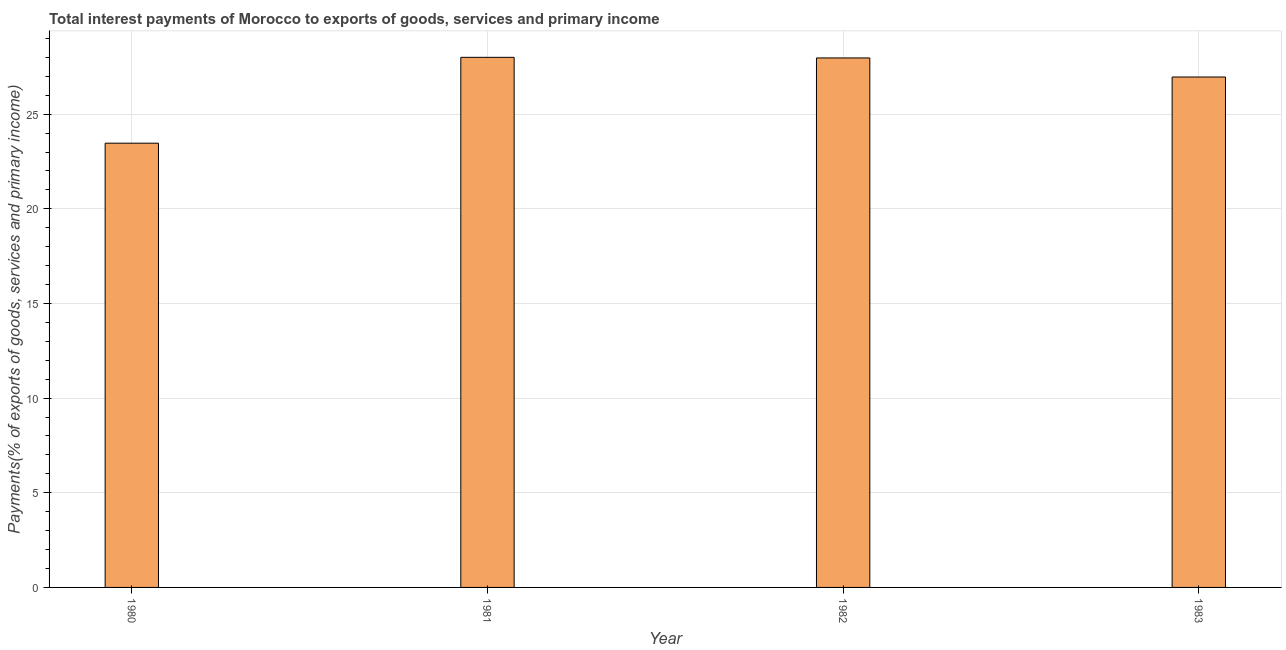Does the graph contain any zero values?
Offer a terse response. No. What is the title of the graph?
Offer a very short reply. Total interest payments of Morocco to exports of goods, services and primary income. What is the label or title of the Y-axis?
Keep it short and to the point. Payments(% of exports of goods, services and primary income). What is the total interest payments on external debt in 1981?
Provide a short and direct response. 28. Across all years, what is the maximum total interest payments on external debt?
Offer a terse response. 28. Across all years, what is the minimum total interest payments on external debt?
Offer a terse response. 23.47. In which year was the total interest payments on external debt minimum?
Offer a very short reply. 1980. What is the sum of the total interest payments on external debt?
Offer a very short reply. 106.41. What is the difference between the total interest payments on external debt in 1980 and 1982?
Provide a short and direct response. -4.5. What is the average total interest payments on external debt per year?
Provide a short and direct response. 26.6. What is the median total interest payments on external debt?
Provide a short and direct response. 27.47. What is the ratio of the total interest payments on external debt in 1980 to that in 1982?
Your answer should be very brief. 0.84. Is the total interest payments on external debt in 1980 less than that in 1982?
Your response must be concise. Yes. What is the difference between the highest and the second highest total interest payments on external debt?
Offer a very short reply. 0.03. What is the difference between the highest and the lowest total interest payments on external debt?
Give a very brief answer. 4.53. In how many years, is the total interest payments on external debt greater than the average total interest payments on external debt taken over all years?
Provide a succinct answer. 3. How many bars are there?
Your answer should be compact. 4. Are the values on the major ticks of Y-axis written in scientific E-notation?
Your answer should be very brief. No. What is the Payments(% of exports of goods, services and primary income) in 1980?
Give a very brief answer. 23.47. What is the Payments(% of exports of goods, services and primary income) of 1981?
Offer a terse response. 28. What is the Payments(% of exports of goods, services and primary income) in 1982?
Provide a short and direct response. 27.97. What is the Payments(% of exports of goods, services and primary income) of 1983?
Keep it short and to the point. 26.96. What is the difference between the Payments(% of exports of goods, services and primary income) in 1980 and 1981?
Offer a terse response. -4.53. What is the difference between the Payments(% of exports of goods, services and primary income) in 1980 and 1982?
Provide a succinct answer. -4.5. What is the difference between the Payments(% of exports of goods, services and primary income) in 1980 and 1983?
Your answer should be compact. -3.5. What is the difference between the Payments(% of exports of goods, services and primary income) in 1981 and 1982?
Your answer should be very brief. 0.03. What is the difference between the Payments(% of exports of goods, services and primary income) in 1981 and 1983?
Provide a succinct answer. 1.04. What is the difference between the Payments(% of exports of goods, services and primary income) in 1982 and 1983?
Your answer should be very brief. 1.01. What is the ratio of the Payments(% of exports of goods, services and primary income) in 1980 to that in 1981?
Your answer should be compact. 0.84. What is the ratio of the Payments(% of exports of goods, services and primary income) in 1980 to that in 1982?
Offer a very short reply. 0.84. What is the ratio of the Payments(% of exports of goods, services and primary income) in 1980 to that in 1983?
Keep it short and to the point. 0.87. What is the ratio of the Payments(% of exports of goods, services and primary income) in 1981 to that in 1983?
Give a very brief answer. 1.04. What is the ratio of the Payments(% of exports of goods, services and primary income) in 1982 to that in 1983?
Provide a succinct answer. 1.04. 